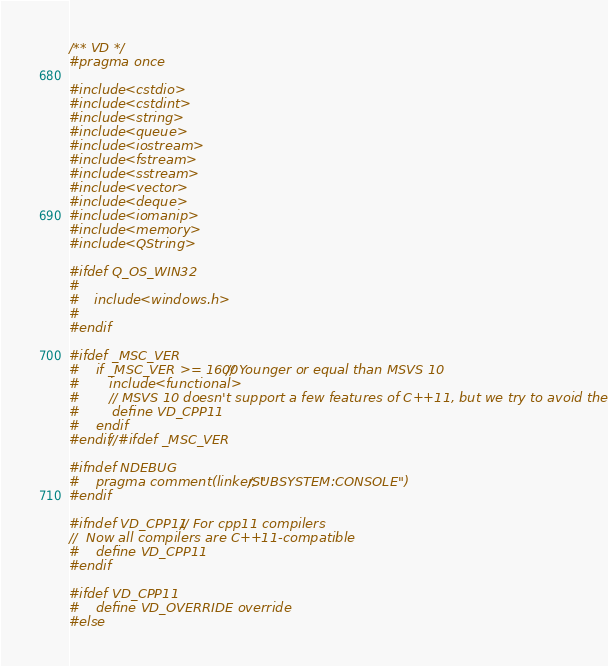<code> <loc_0><loc_0><loc_500><loc_500><_C++_>/** VD */
#pragma once

#include <cstdio>
#include <cstdint>
#include <string>
#include <queue>
#include <iostream>
#include <fstream>
#include <sstream>
#include <vector>
#include <deque>
#include <iomanip>
#include <memory>
#include <QString>

#ifdef Q_OS_WIN32
#
#	include <windows.h>
#
#endif

#ifdef _MSC_VER
#	if _MSC_VER >= 1600 // Younger or equal than MSVS 10
#		include <functional>
#		// MSVS 10 doesn't support a few features of C++11, but we try to avoid them
#		define VD_CPP11
#	endif
#endif//#ifdef _MSC_VER

#ifndef NDEBUG
#	pragma comment(linker, "/SUBSYSTEM:CONSOLE")
#endif

#ifndef VD_CPP11 // For cpp11 compilers
//	Now all compilers are C++11-compatible
#	define VD_CPP11 
#endif

#ifdef VD_CPP11
#	define VD_OVERRIDE override
#else</code> 